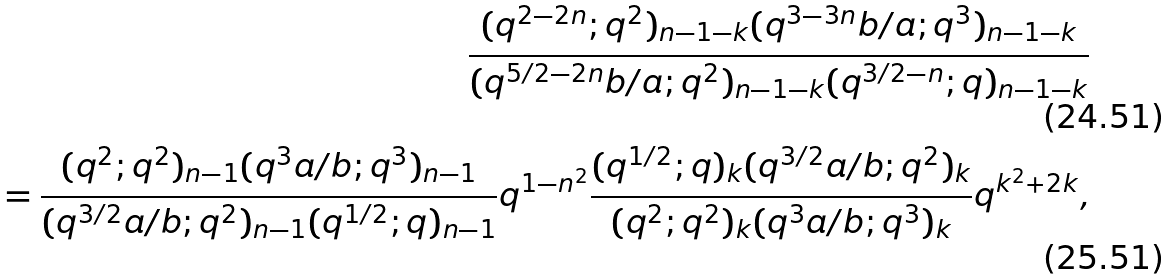Convert formula to latex. <formula><loc_0><loc_0><loc_500><loc_500>\frac { ( q ^ { 2 - 2 n } ; q ^ { 2 } ) _ { n - 1 - k } ( q ^ { 3 - 3 n } b / a ; q ^ { 3 } ) _ { n - 1 - k } } { ( q ^ { 5 / 2 - 2 n } b / a ; q ^ { 2 } ) _ { n - 1 - k } ( q ^ { 3 / 2 - n } ; q ) _ { n - 1 - k } } \\ = \frac { ( q ^ { 2 } ; q ^ { 2 } ) _ { n - 1 } ( q ^ { 3 } a / b ; q ^ { 3 } ) _ { n - 1 } } { ( q ^ { 3 / 2 } a / b ; q ^ { 2 } ) _ { n - 1 } ( q ^ { 1 / 2 } ; q ) _ { n - 1 } } q ^ { 1 - n ^ { 2 } } \frac { ( q ^ { 1 / 2 } ; q ) _ { k } ( q ^ { 3 / 2 } a / b ; q ^ { 2 } ) _ { k } } { ( q ^ { 2 } ; q ^ { 2 } ) _ { k } ( q ^ { 3 } a / b ; q ^ { 3 } ) _ { k } } q ^ { k ^ { 2 } + 2 k } ,</formula> 